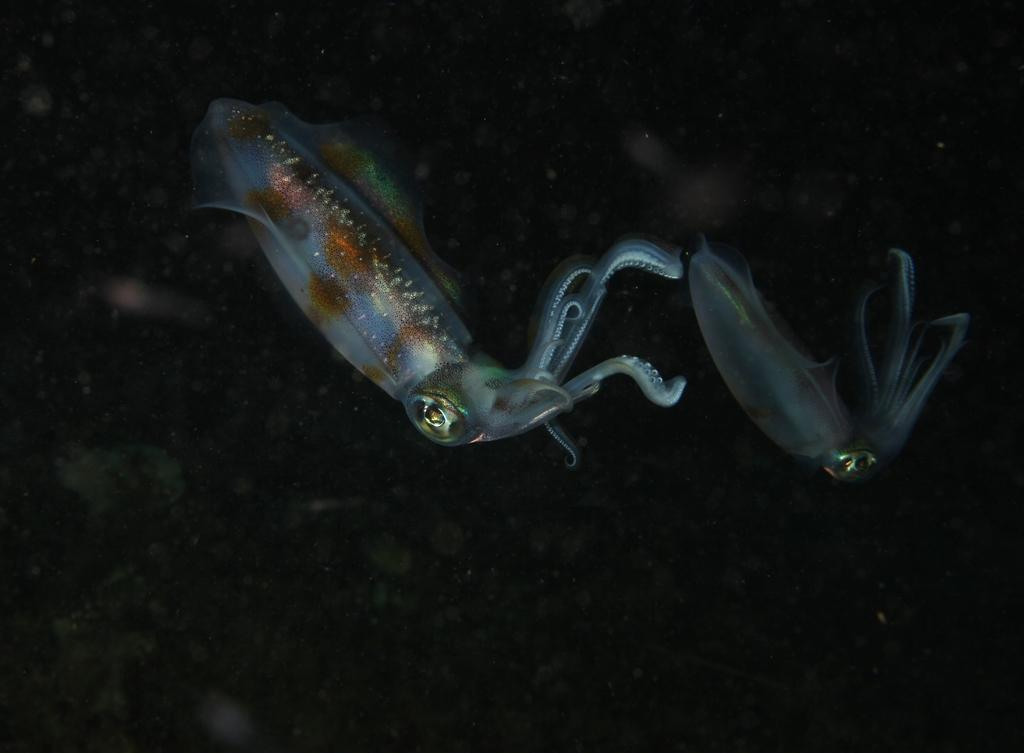What type of animals are present in the image? There are squids in the image. Where are the squids located? The squids are in a water body. What type of calculator can be seen in the image? There is no calculator present in the image; it features squids in a water body. Is there a tiger visible in the image? No, there is no tiger present in the image. 